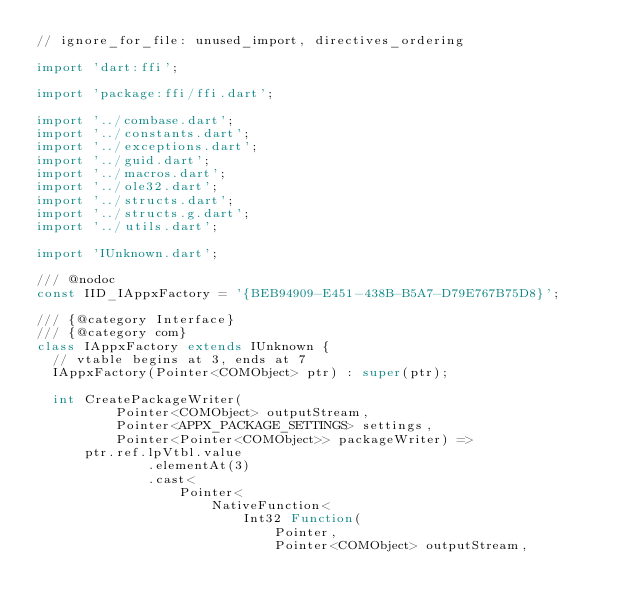<code> <loc_0><loc_0><loc_500><loc_500><_Dart_>// ignore_for_file: unused_import, directives_ordering

import 'dart:ffi';

import 'package:ffi/ffi.dart';

import '../combase.dart';
import '../constants.dart';
import '../exceptions.dart';
import '../guid.dart';
import '../macros.dart';
import '../ole32.dart';
import '../structs.dart';
import '../structs.g.dart';
import '../utils.dart';

import 'IUnknown.dart';

/// @nodoc
const IID_IAppxFactory = '{BEB94909-E451-438B-B5A7-D79E767B75D8}';

/// {@category Interface}
/// {@category com}
class IAppxFactory extends IUnknown {
  // vtable begins at 3, ends at 7
  IAppxFactory(Pointer<COMObject> ptr) : super(ptr);

  int CreatePackageWriter(
          Pointer<COMObject> outputStream,
          Pointer<APPX_PACKAGE_SETTINGS> settings,
          Pointer<Pointer<COMObject>> packageWriter) =>
      ptr.ref.lpVtbl.value
              .elementAt(3)
              .cast<
                  Pointer<
                      NativeFunction<
                          Int32 Function(
                              Pointer,
                              Pointer<COMObject> outputStream,</code> 